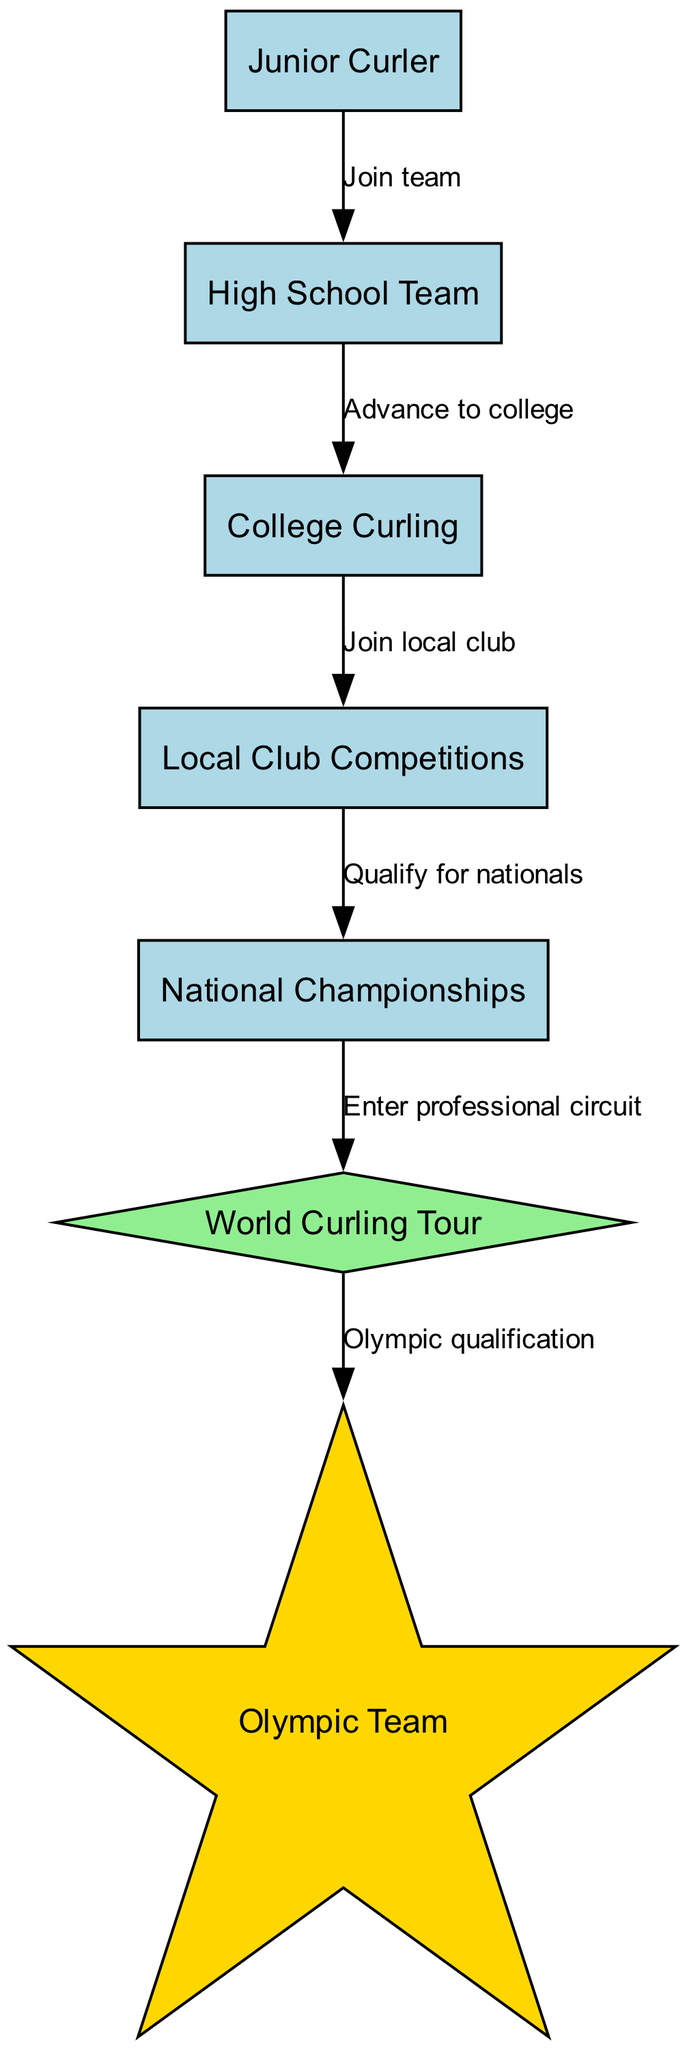What is the first step in the progression of a curler's career? The first node in the diagram is "Junior Curler", which represents the starting position in the career progression.
Answer: Junior Curler How many nodes are there in total? Counting all the distinct elements in the diagram, we identify seven different positions represented by nodes.
Answer: 7 What does the edge from "Local Club Competitions" to "National Championships" signify? The edge indicates that to advance from local competitions, a curler must qualify for the national championships, as shown by the label "Qualify for nationals".
Answer: Qualify for nationals What happens after "World Curling Tour"? According to the diagram, after entering the World Curling Tour, the next step is "Olympic Team", which is reached after achieving Olympic qualification as indicated by the edge.
Answer: Olympic Team What is the shape of the "Olympic Team" node? The "Olympic Team" node is uniquely marked with a star shape, differentiating it from the others which are rectangle-shaped nodes.
Answer: Star How does one transition from "High School Team" to "College Curling"? The edge between these two nodes is labeled "Advance to college", indicating that a curler progresses to college-level curling from high school teams.
Answer: Advance to college Which node represents the professional level of curling? The "World Curling Tour" node symbolizes the professional level of curling within the career progression outlined in the diagram.
Answer: World Curling Tour What must a curler do to reach the "Olympic Team"? According to the diagram, the edge leading to "Olympic Team" is labeled "Olympic qualification", indicating that qualification is required for this step.
Answer: Olympic qualification What is the relationship between "National Championships" and "World Curling Tour"? The edge connects "National Championships" to "World Curling Tour" with the label "Enter professional circuit", indicating that participation in nationals is required to enter the professional level.
Answer: Enter professional circuit 